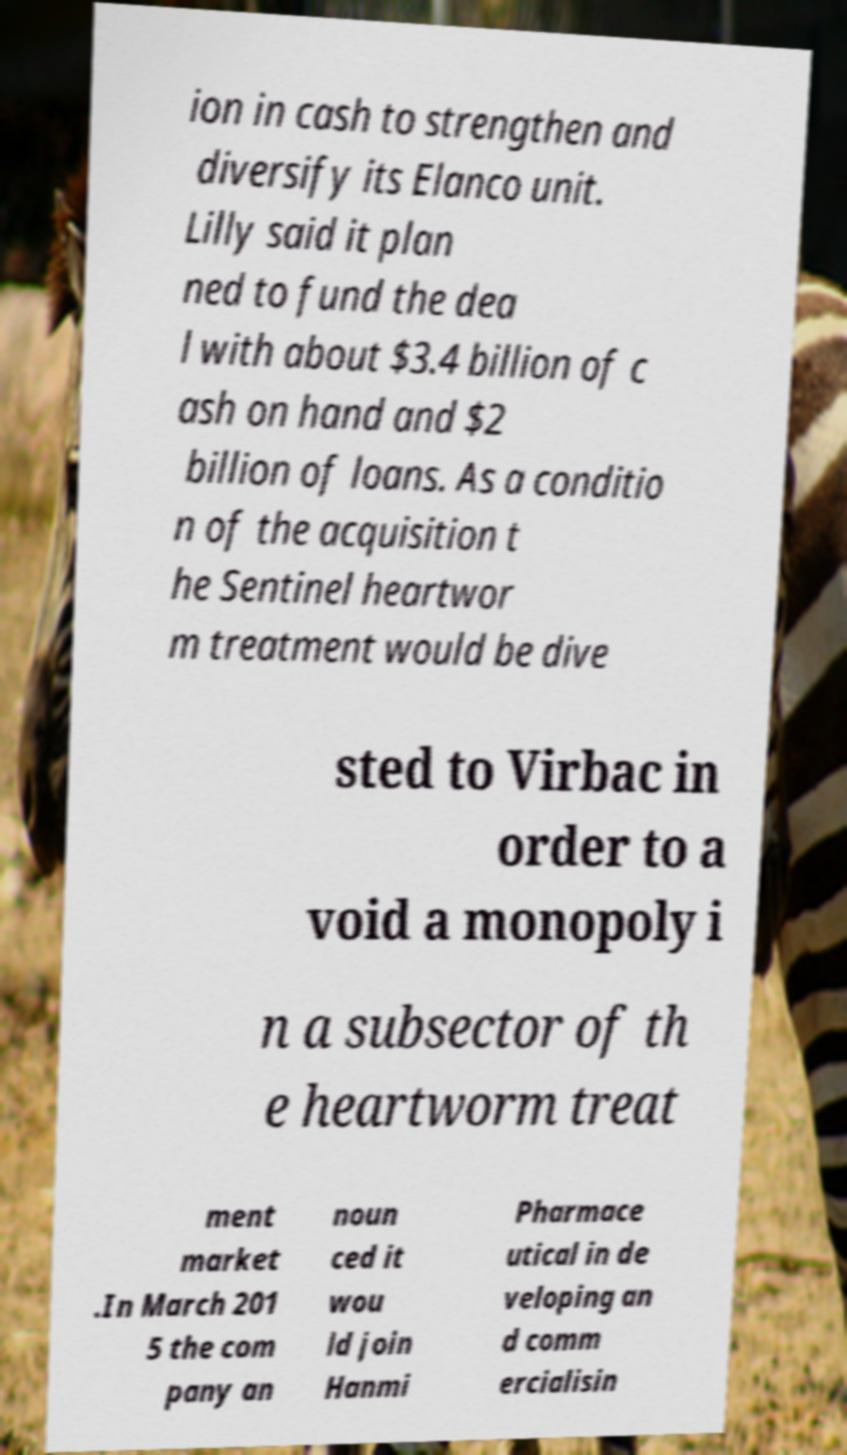I need the written content from this picture converted into text. Can you do that? ion in cash to strengthen and diversify its Elanco unit. Lilly said it plan ned to fund the dea l with about $3.4 billion of c ash on hand and $2 billion of loans. As a conditio n of the acquisition t he Sentinel heartwor m treatment would be dive sted to Virbac in order to a void a monopoly i n a subsector of th e heartworm treat ment market .In March 201 5 the com pany an noun ced it wou ld join Hanmi Pharmace utical in de veloping an d comm ercialisin 